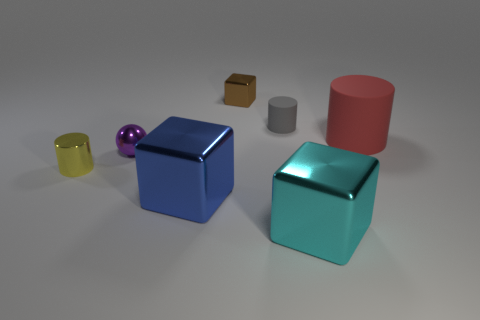Subtract all brown cylinders. Subtract all green spheres. How many cylinders are left? 3 Subtract all cyan balls. How many gray blocks are left? 0 Add 6 tiny yellows. How many cyans exist? 0 Subtract all large rubber cylinders. Subtract all big cyan objects. How many objects are left? 5 Add 6 big matte cylinders. How many big matte cylinders are left? 7 Add 5 large green matte cylinders. How many large green matte cylinders exist? 5 Add 1 big blue spheres. How many objects exist? 8 Subtract all red cylinders. How many cylinders are left? 2 Subtract all small gray matte cylinders. How many cylinders are left? 2 Subtract 0 red spheres. How many objects are left? 7 